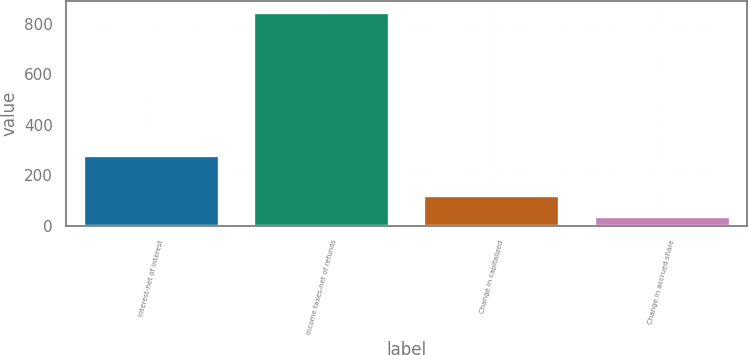Convert chart. <chart><loc_0><loc_0><loc_500><loc_500><bar_chart><fcel>Interest-net of interest<fcel>Income taxes-net of refunds<fcel>Change in capitalized<fcel>Change in accrued share<nl><fcel>282.43<fcel>847.4<fcel>121.01<fcel>40.3<nl></chart> 